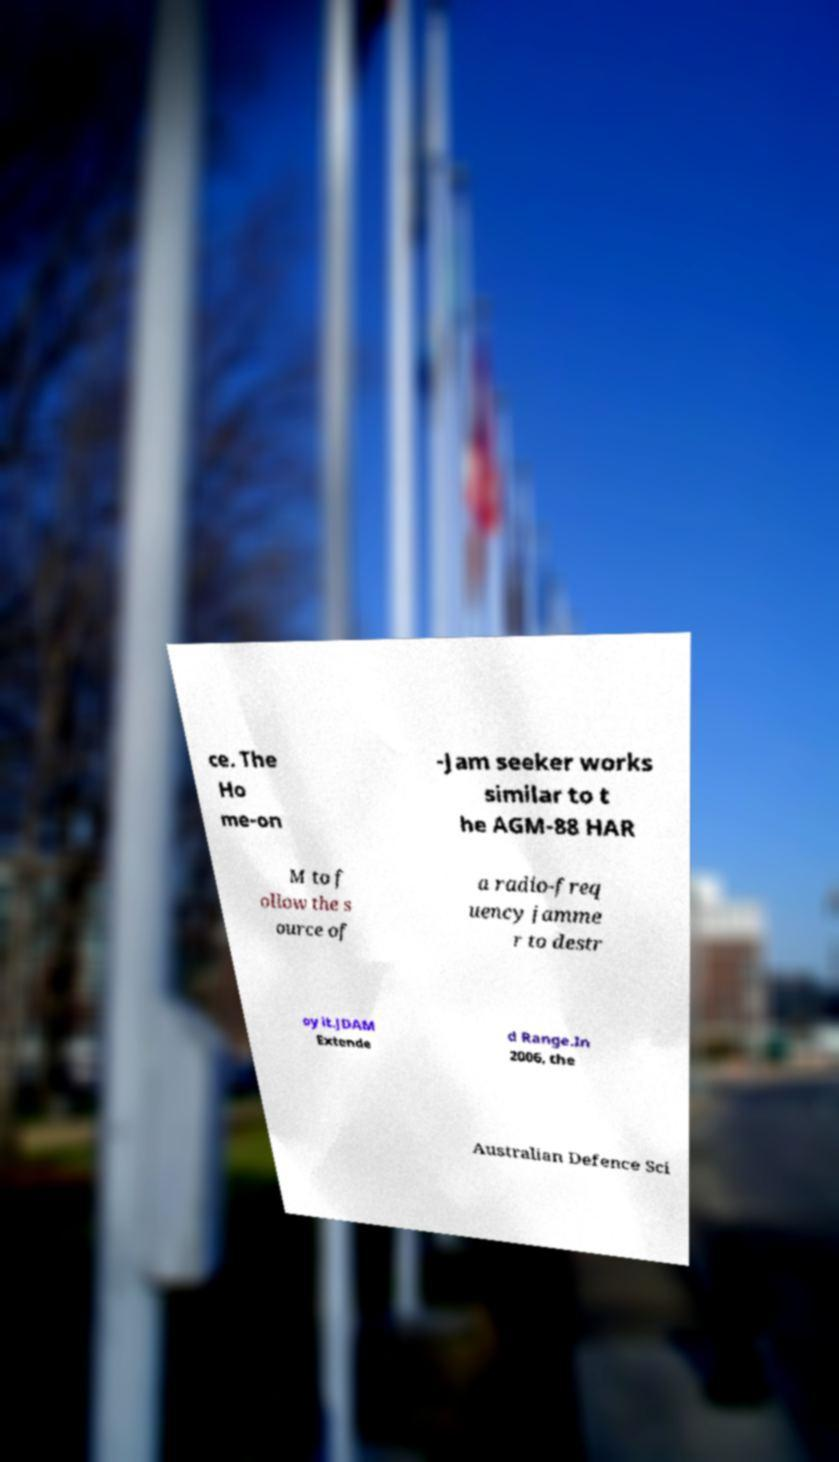Could you assist in decoding the text presented in this image and type it out clearly? ce. The Ho me-on -Jam seeker works similar to t he AGM-88 HAR M to f ollow the s ource of a radio-freq uency jamme r to destr oy it.JDAM Extende d Range.In 2006, the Australian Defence Sci 